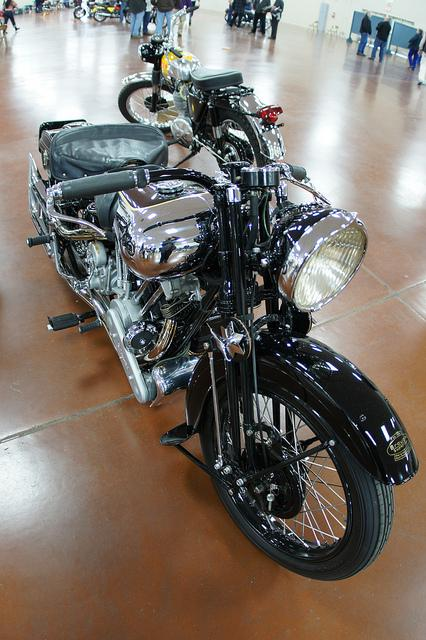What is the large glass object on the bike called? headlight 